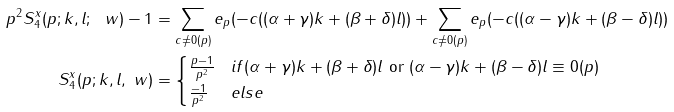Convert formula to latex. <formula><loc_0><loc_0><loc_500><loc_500>p ^ { 2 } S _ { 4 } ^ { x } ( p ; k , l ; \ w ) - 1 & = \sum _ { c \neq 0 ( p ) } e _ { p } ( - c ( ( \alpha + \gamma ) k + ( \beta + \delta ) l ) ) + \sum _ { c \neq 0 ( p ) } e _ { p } ( - c ( ( \alpha - \gamma ) k + ( \beta - \delta ) l ) ) \\ S _ { 4 } ^ { x } ( p ; k , l , \ w ) & = \begin{cases} \frac { p - 1 } { p ^ { 2 } } & i f ( \alpha + \gamma ) k + ( \beta + \delta ) l \text { or } ( \alpha - \gamma ) k + ( \beta - \delta ) l \equiv 0 ( p ) \\ \frac { - 1 } { p ^ { 2 } } & e l s e \\ \end{cases}</formula> 